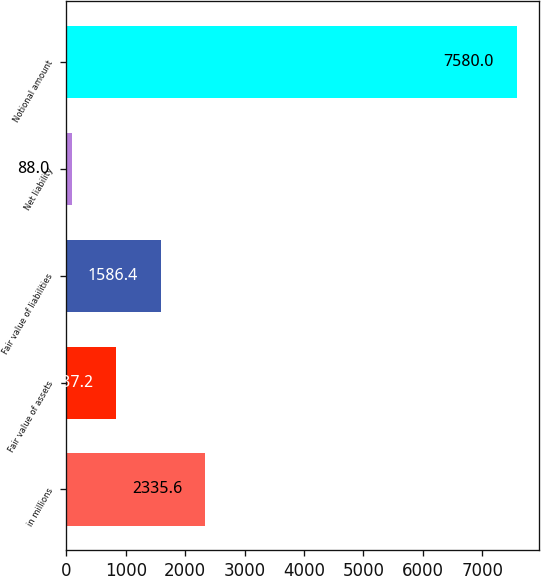<chart> <loc_0><loc_0><loc_500><loc_500><bar_chart><fcel>in millions<fcel>Fair value of assets<fcel>Fair value of liabilities<fcel>Net liability<fcel>Notional amount<nl><fcel>2335.6<fcel>837.2<fcel>1586.4<fcel>88<fcel>7580<nl></chart> 